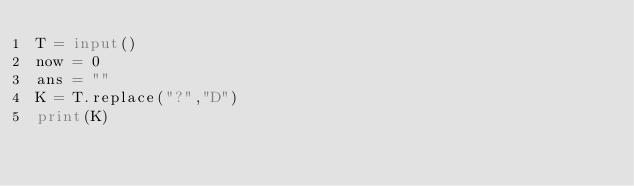<code> <loc_0><loc_0><loc_500><loc_500><_Python_>T = input()
now = 0
ans = ""
K = T.replace("?","D")
print(K)</code> 